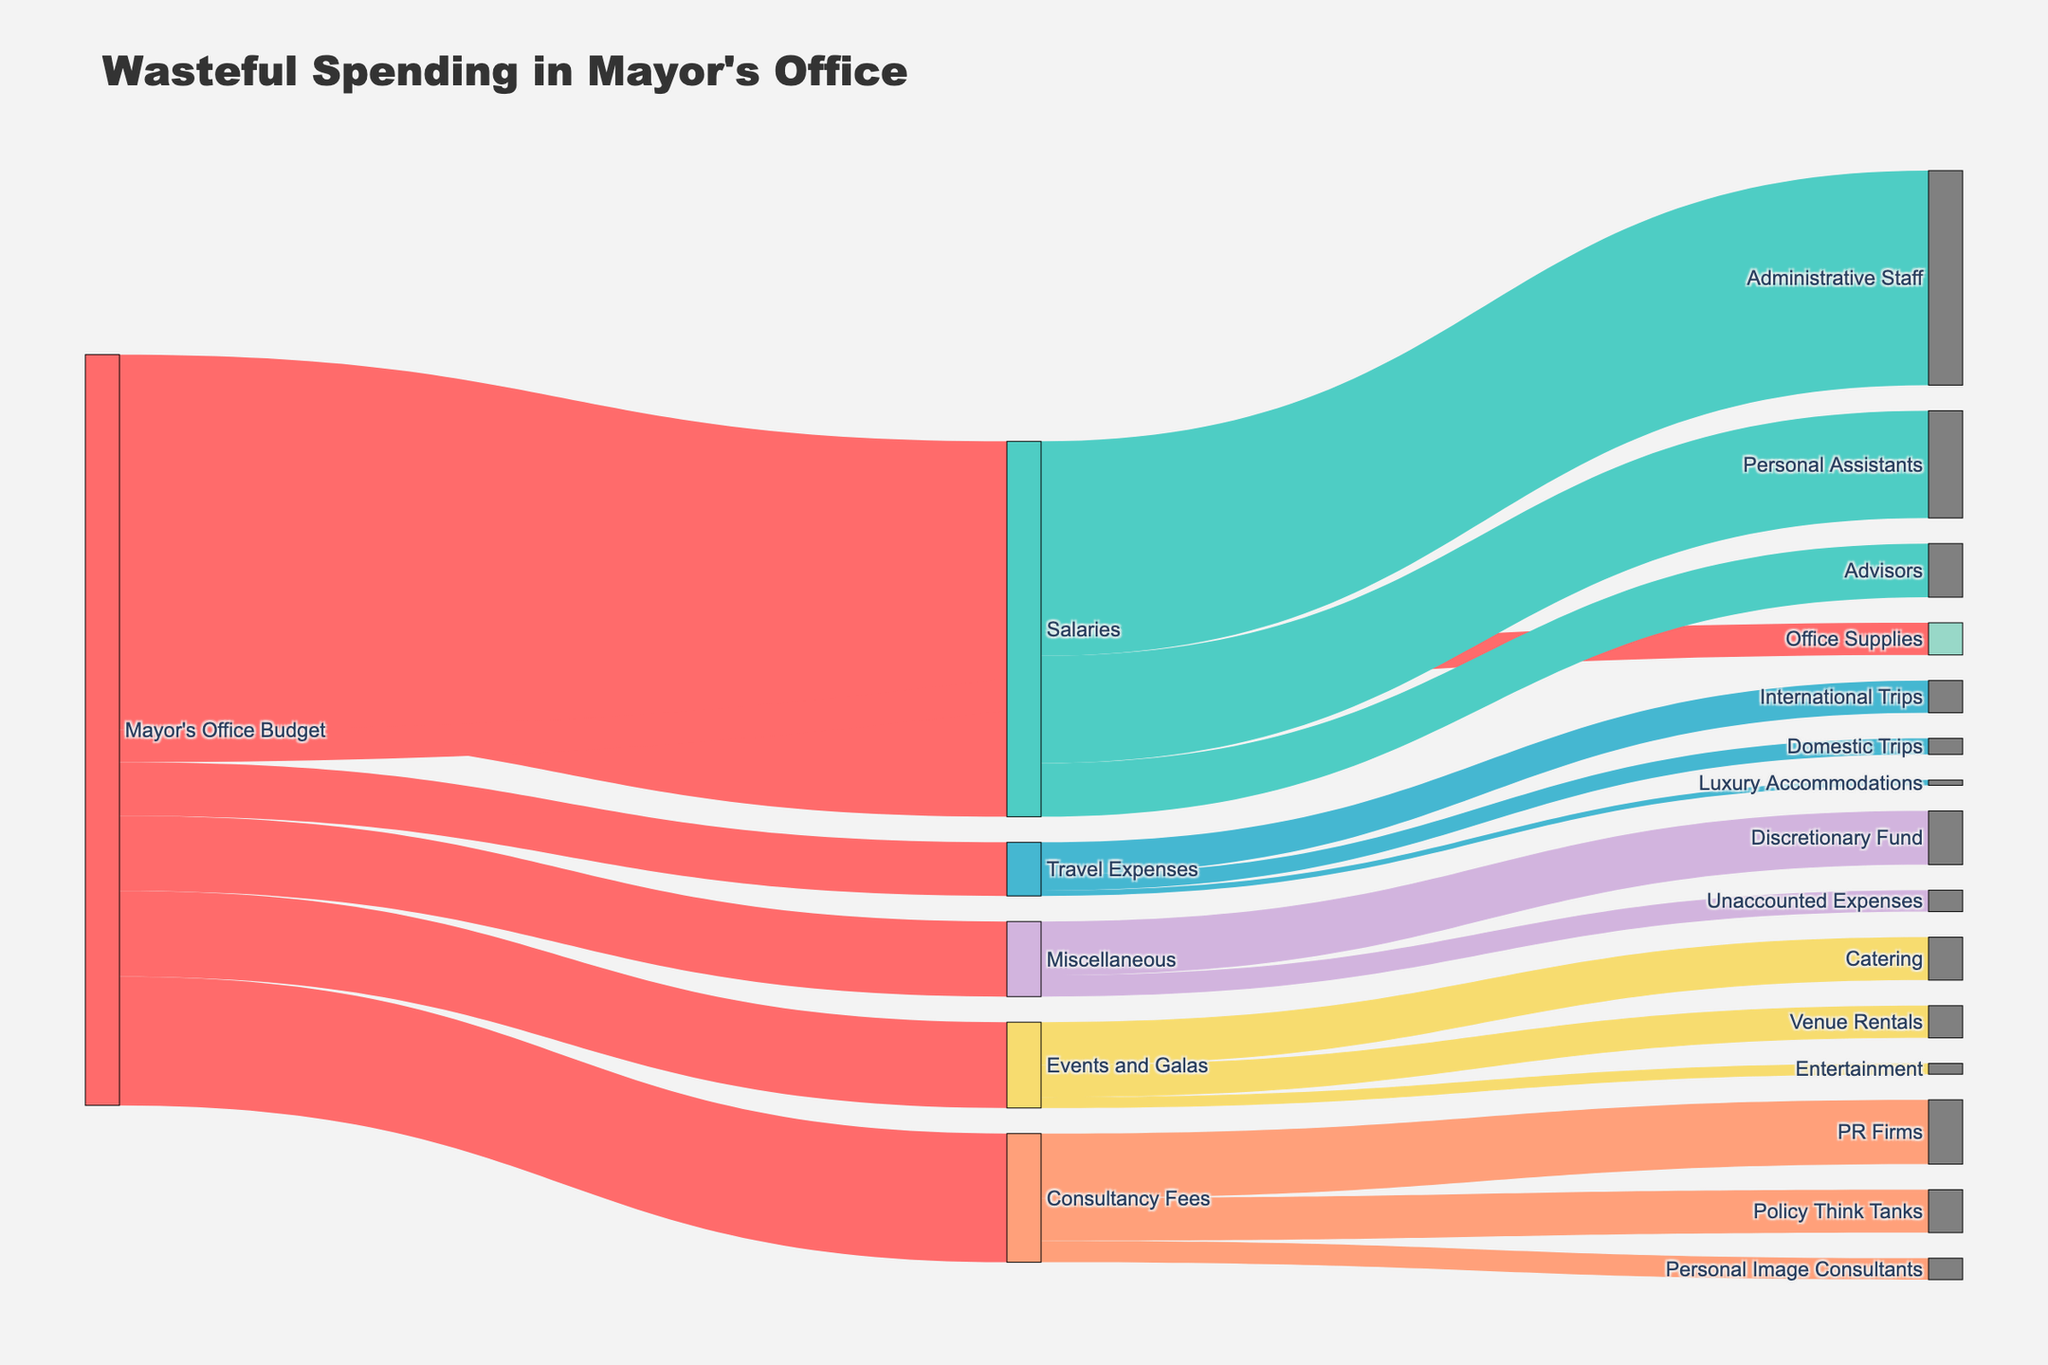What is the largest expenditure under the Mayor's Office Budget? The figure shows various budget allocations from the Mayor's Office Budget. Salaries receive the largest allocation at $3,500,000.
Answer: $3,500,000 What is the total amount spent on travel expenses? The diagram shows three categories under Travel Expenses: International Trips ($300,000), Domestic Trips ($150,000), and Luxury Accommodations ($50,000). Adding these gives $300,000 + $150,000 + $50,000 = $500,000.
Answer: $500,000 How much is spent on Personal Image Consultants compared to PR Firms? The allocation for Personal Image Consultants is $200,000, while PR Firms receive $600,000 under Consultancy Fees. Comparing these amounts, PR Firms receive more.
Answer: PR Firms receive more What is the total allocation for consultancy fees? The diagram breaks down Consultancy Fees into PR Firms ($600,000), Policy Think Tanks ($400,000), and Personal Image Consultants ($200,000). Adding these gives $600,000 + $400,000 + $200,000 = $1,200,000.
Answer: $1,200,000 Which has a higher allocation: Events and Galas or Miscellaneous expenses? Events and Galas are allocated $800,000, whereas Miscellaneous expenses receive $700,000. Events and Galas have a higher allocation.
Answer: Events and Galas Which individual category under Events and Galas has the highest expenditure? The figure shows three categories: Catering ($400,000), Venue Rentals ($300,000), and Entertainment ($100,000). Catering has the highest expenditure among these.
Answer: Catering How much is the Discretionary Fund compared to Office Supplies? The Discretionary Fund under Miscellaneous is $500,000, while Office Supplies receive $300,000 from the Mayor's Office Budget. The Discretionary Fund is larger by $200,000.
Answer: The Discretionary Fund by $200,000 What is the smallest individual expenditure? The smallest individual expenditure shown in the figure is for Luxury Accommodations under Travel Expenses, amounting to $50,000.
Answer: $50,000 What portion of the Salary budget is allocated to Advisors? The Salary budget is $3,500,000, and Advisors receive $500,000. The portion is calculated as $500,000 / $3,500,000 = 1/7, which simplifies to approximately 14.29%.
Answer: Approximately 14.29% Which category under Miscellaneous has larger expenses? Miscellaneous includes the Discretionary Fund ($500,000) and Unaccounted Expenses ($200,000). The Discretionary Fund has larger expenses.
Answer: The Discretionary Fund 